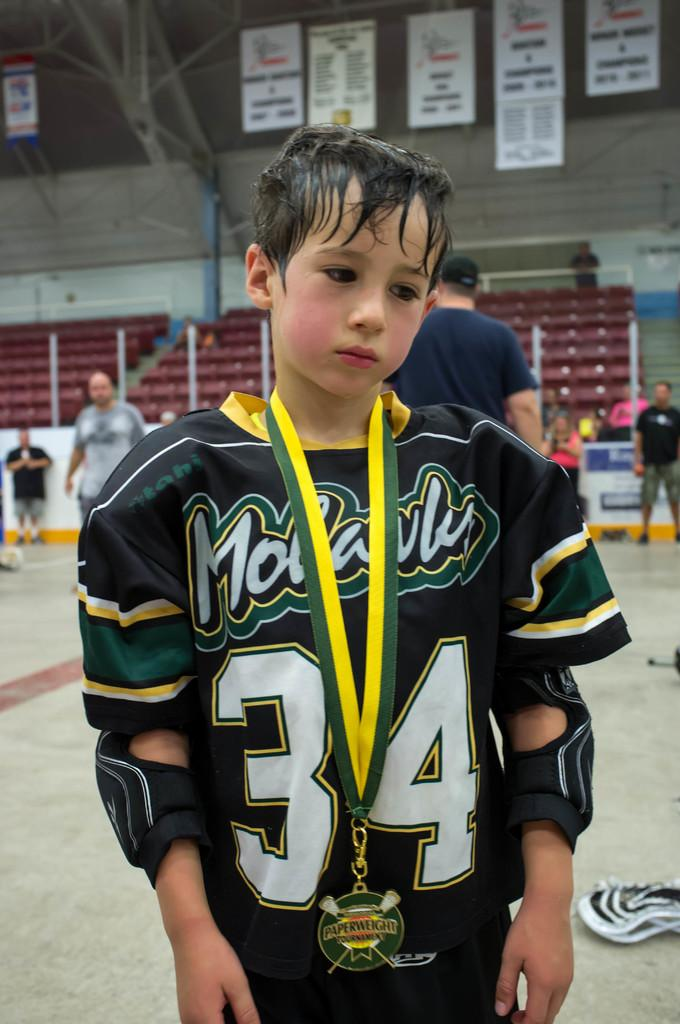<image>
Summarize the visual content of the image. A young boy standing in a gym wearing a green,white and yellow jersey and has a medal that says paperweight. 